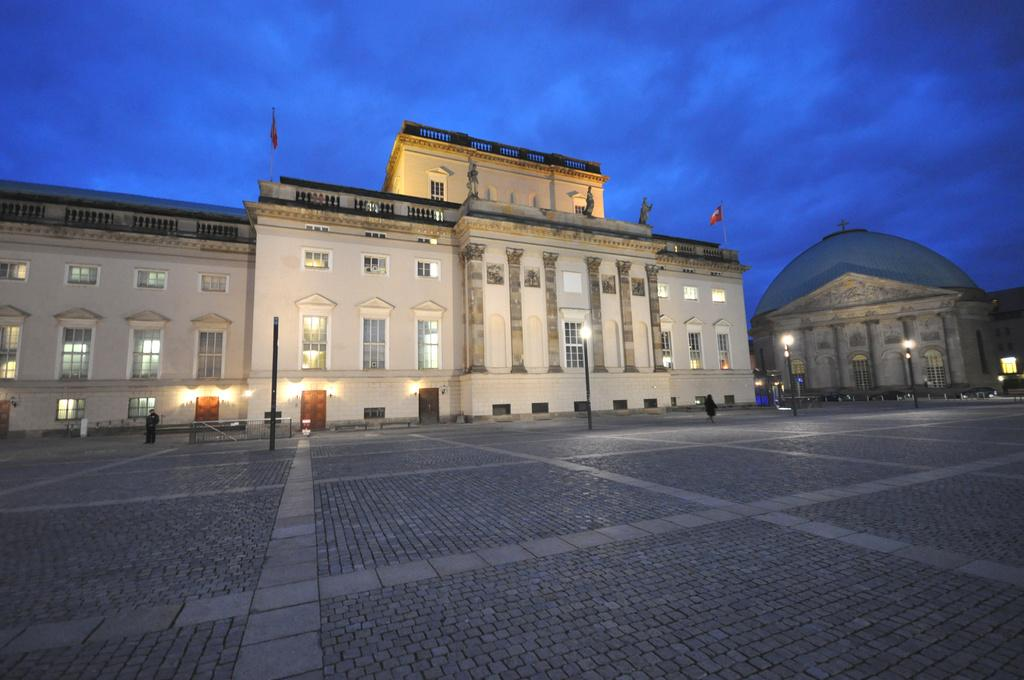What type of structures can be seen in the image? There are buildings in the image. How many flags are present in the image? There are 2 flags in the image. What type of lighting is present in the image? There are street lights in the image. What type of path is visible in the image? There is a path in the image. What can be seen in the background of the image? The sky is visible in the background of the image. What is the condition of the sky in the image? The sky is cloudy in the image. What type of beef is being served in the shade of the building in the image? There is no beef or shade present in the image; it only features buildings, flags, street lights, a path, and a cloudy sky. 